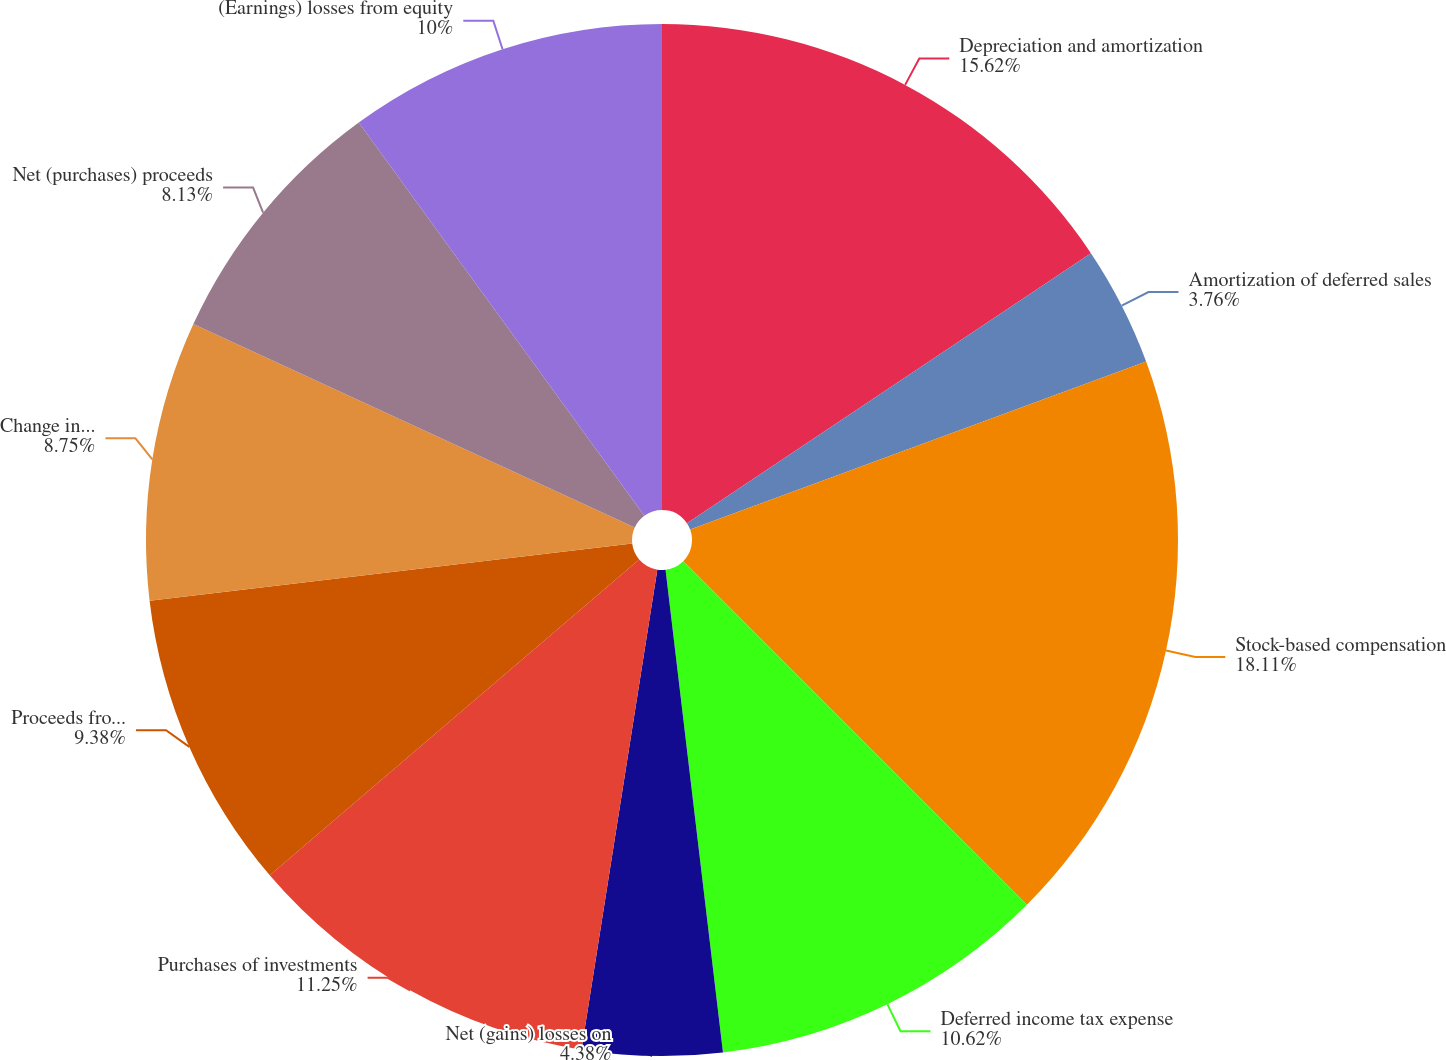<chart> <loc_0><loc_0><loc_500><loc_500><pie_chart><fcel>Depreciation and amortization<fcel>Amortization of deferred sales<fcel>Stock-based compensation<fcel>Deferred income tax expense<fcel>Net (gains) losses on<fcel>Purchases of investments<fcel>Proceeds from sales and<fcel>Change in cash and cash<fcel>Net (purchases) proceeds<fcel>(Earnings) losses from equity<nl><fcel>15.62%<fcel>3.76%<fcel>18.12%<fcel>10.62%<fcel>4.38%<fcel>11.25%<fcel>9.38%<fcel>8.75%<fcel>8.13%<fcel>10.0%<nl></chart> 